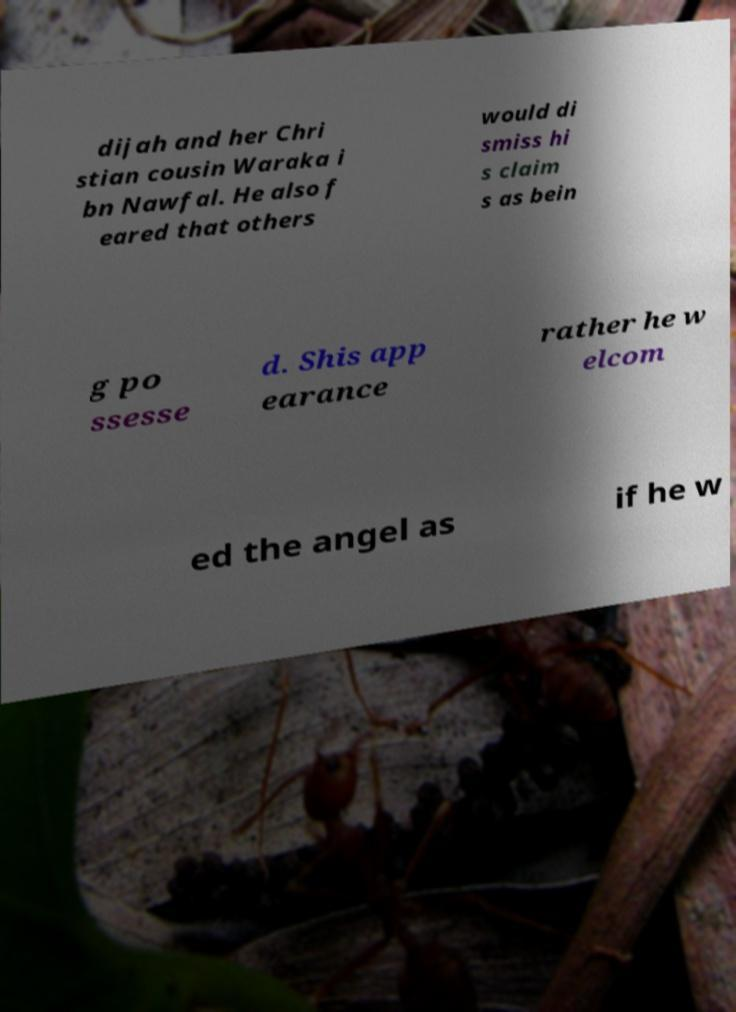For documentation purposes, I need the text within this image transcribed. Could you provide that? dijah and her Chri stian cousin Waraka i bn Nawfal. He also f eared that others would di smiss hi s claim s as bein g po ssesse d. Shis app earance rather he w elcom ed the angel as if he w 